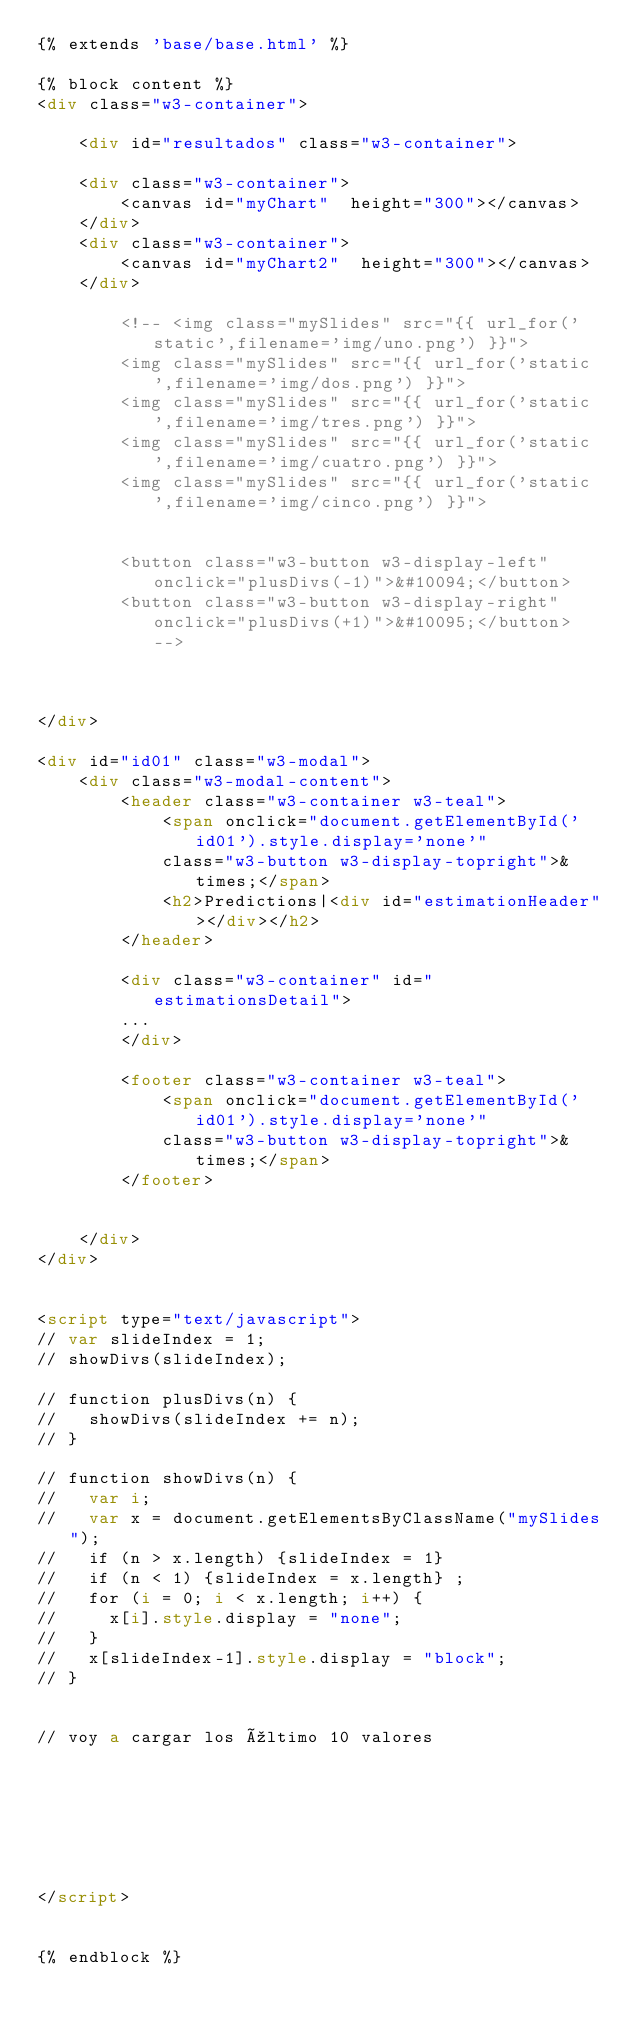Convert code to text. <code><loc_0><loc_0><loc_500><loc_500><_HTML_>{% extends 'base/base.html' %}

{% block content %}
<div class="w3-container">
    
    <div id="resultados" class="w3-container">
        
    <div class="w3-container">
        <canvas id="myChart"  height="300"></canvas>
    </div>
    <div class="w3-container">
        <canvas id="myChart2"  height="300"></canvas>
    </div>
        
        <!-- <img class="mySlides" src="{{ url_for('static',filename='img/uno.png') }}">
        <img class="mySlides" src="{{ url_for('static',filename='img/dos.png') }}">
        <img class="mySlides" src="{{ url_for('static',filename='img/tres.png') }}">
        <img class="mySlides" src="{{ url_for('static',filename='img/cuatro.png') }}">
        <img class="mySlides" src="{{ url_for('static',filename='img/cinco.png') }}">

        
        <button class="w3-button w3-display-left" onclick="plusDivs(-1)">&#10094;</button>
        <button class="w3-button w3-display-right" onclick="plusDivs(+1)">&#10095;</button> -->


        
</div>

<div id="id01" class="w3-modal">
    <div class="w3-modal-content">
        <header class="w3-container w3-teal">
            <span onclick="document.getElementById('id01').style.display='none'"
            class="w3-button w3-display-topright">&times;</span>
            <h2>Predictions|<div id="estimationHeader"></div></h2>
        </header>
      
        <div class="w3-container" id="estimationsDetail">
        ...
        </div>

        <footer class="w3-container w3-teal">
            <span onclick="document.getElementById('id01').style.display='none'"
            class="w3-button w3-display-topright">&times;</span>
        </footer>

      
    </div>
</div>
  

<script type="text/javascript">
// var slideIndex = 1;
// showDivs(slideIndex);

// function plusDivs(n) {
//   showDivs(slideIndex += n);
// }

// function showDivs(n) {
//   var i;
//   var x = document.getElementsByClassName("mySlides");
//   if (n > x.length) {slideIndex = 1}
//   if (n < 1) {slideIndex = x.length} ;
//   for (i = 0; i < x.length; i++) {
//     x[i].style.display = "none";
//   }
//   x[slideIndex-1].style.display = "block";
// }


// voy a cargar los último 10 valores



 

 

</script>


{% endblock %}


          

</code> 